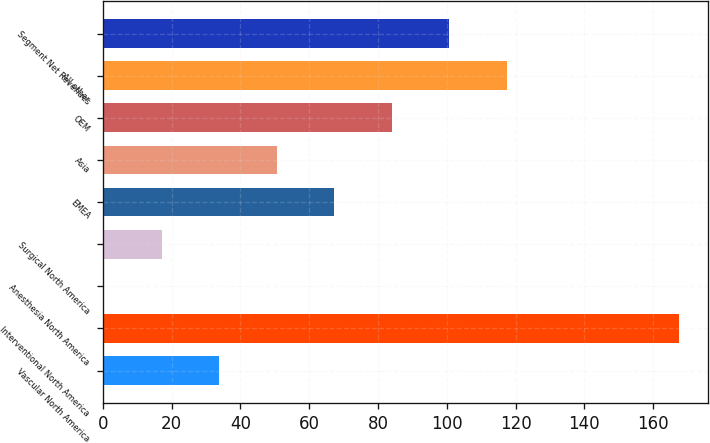Convert chart. <chart><loc_0><loc_0><loc_500><loc_500><bar_chart><fcel>Vascular North America<fcel>Interventional North America<fcel>Anesthesia North America<fcel>Surgical North America<fcel>EMEA<fcel>Asia<fcel>OEM<fcel>All other<fcel>Segment Net Revenues<nl><fcel>33.84<fcel>167.6<fcel>0.4<fcel>17.12<fcel>67.28<fcel>50.56<fcel>84<fcel>117.44<fcel>100.72<nl></chart> 